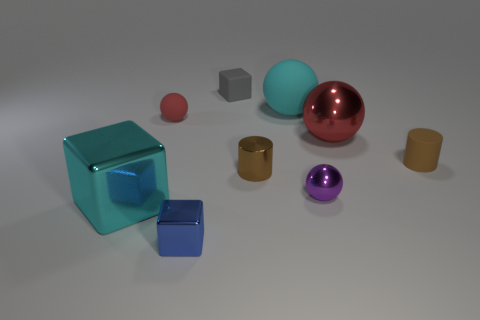How many red balls must be subtracted to get 1 red balls? 1 Subtract all cyan cylinders. How many red balls are left? 2 Subtract all cyan spheres. How many spheres are left? 3 Subtract all small cubes. How many cubes are left? 1 Add 1 purple metal objects. How many objects exist? 10 Subtract all blue spheres. Subtract all gray cubes. How many spheres are left? 4 Subtract all balls. How many objects are left? 5 Add 2 tiny shiny objects. How many tiny shiny objects are left? 5 Add 9 blue matte spheres. How many blue matte spheres exist? 9 Subtract 0 yellow cubes. How many objects are left? 9 